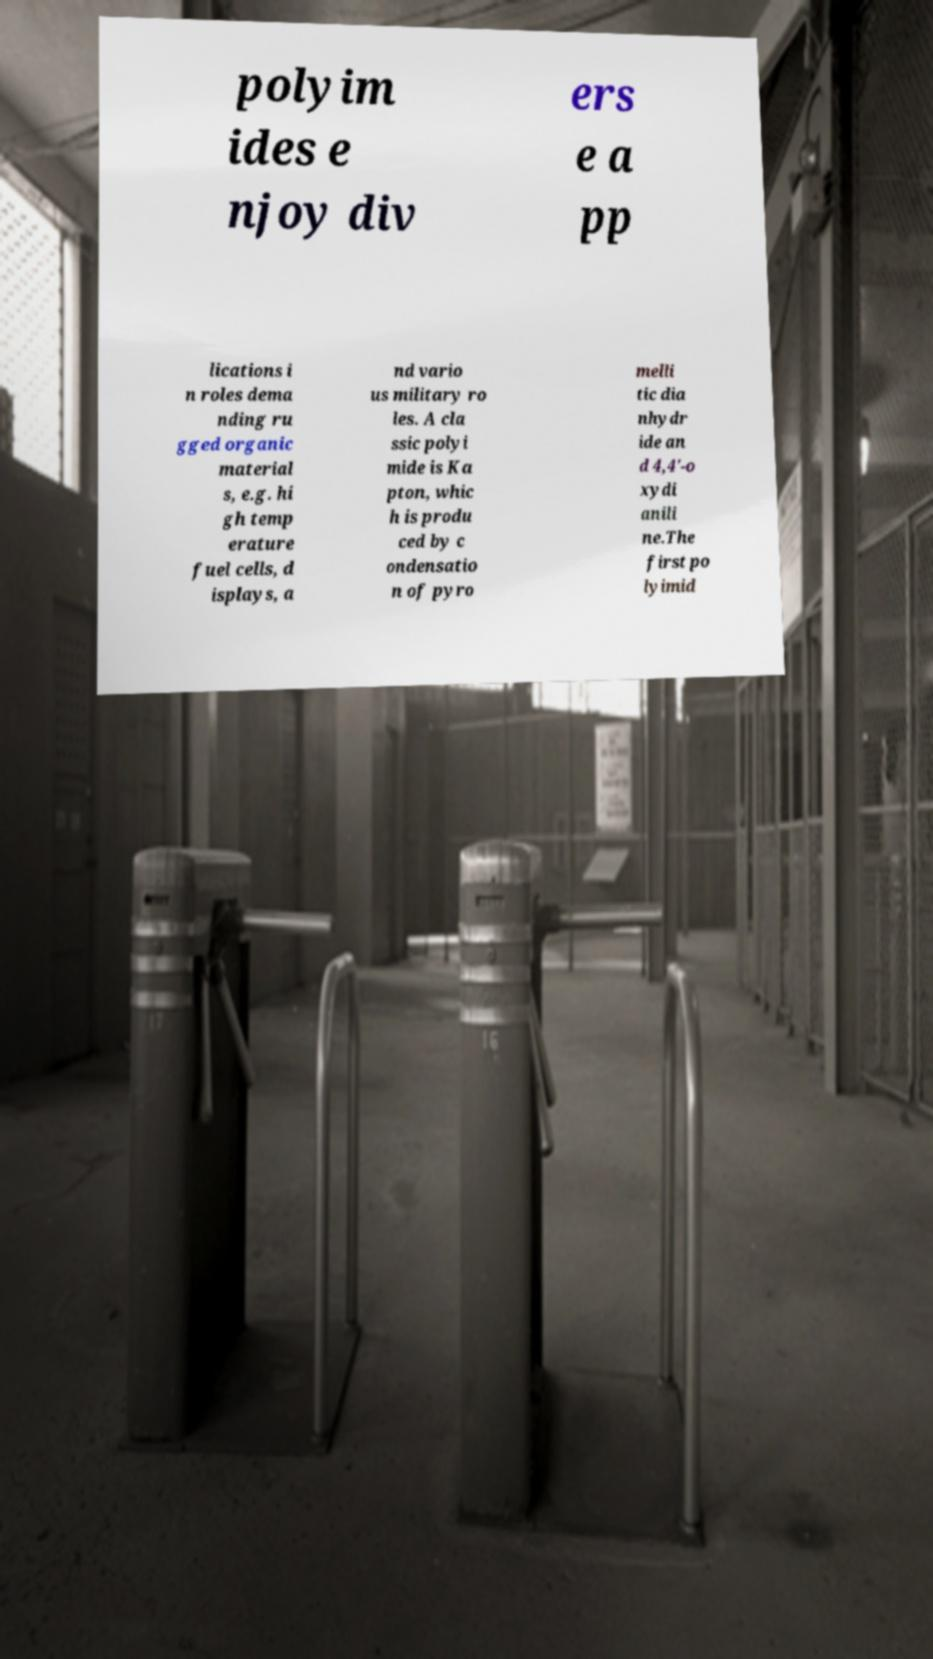There's text embedded in this image that I need extracted. Can you transcribe it verbatim? polyim ides e njoy div ers e a pp lications i n roles dema nding ru gged organic material s, e.g. hi gh temp erature fuel cells, d isplays, a nd vario us military ro les. A cla ssic polyi mide is Ka pton, whic h is produ ced by c ondensatio n of pyro melli tic dia nhydr ide an d 4,4'-o xydi anili ne.The first po lyimid 